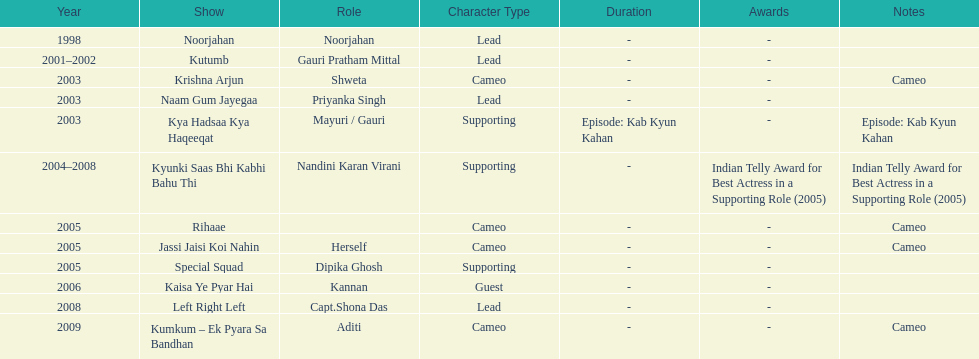The shows with at most 1 cameo Krishna Arjun, Rihaae, Jassi Jaisi Koi Nahin, Kumkum - Ek Pyara Sa Bandhan. 